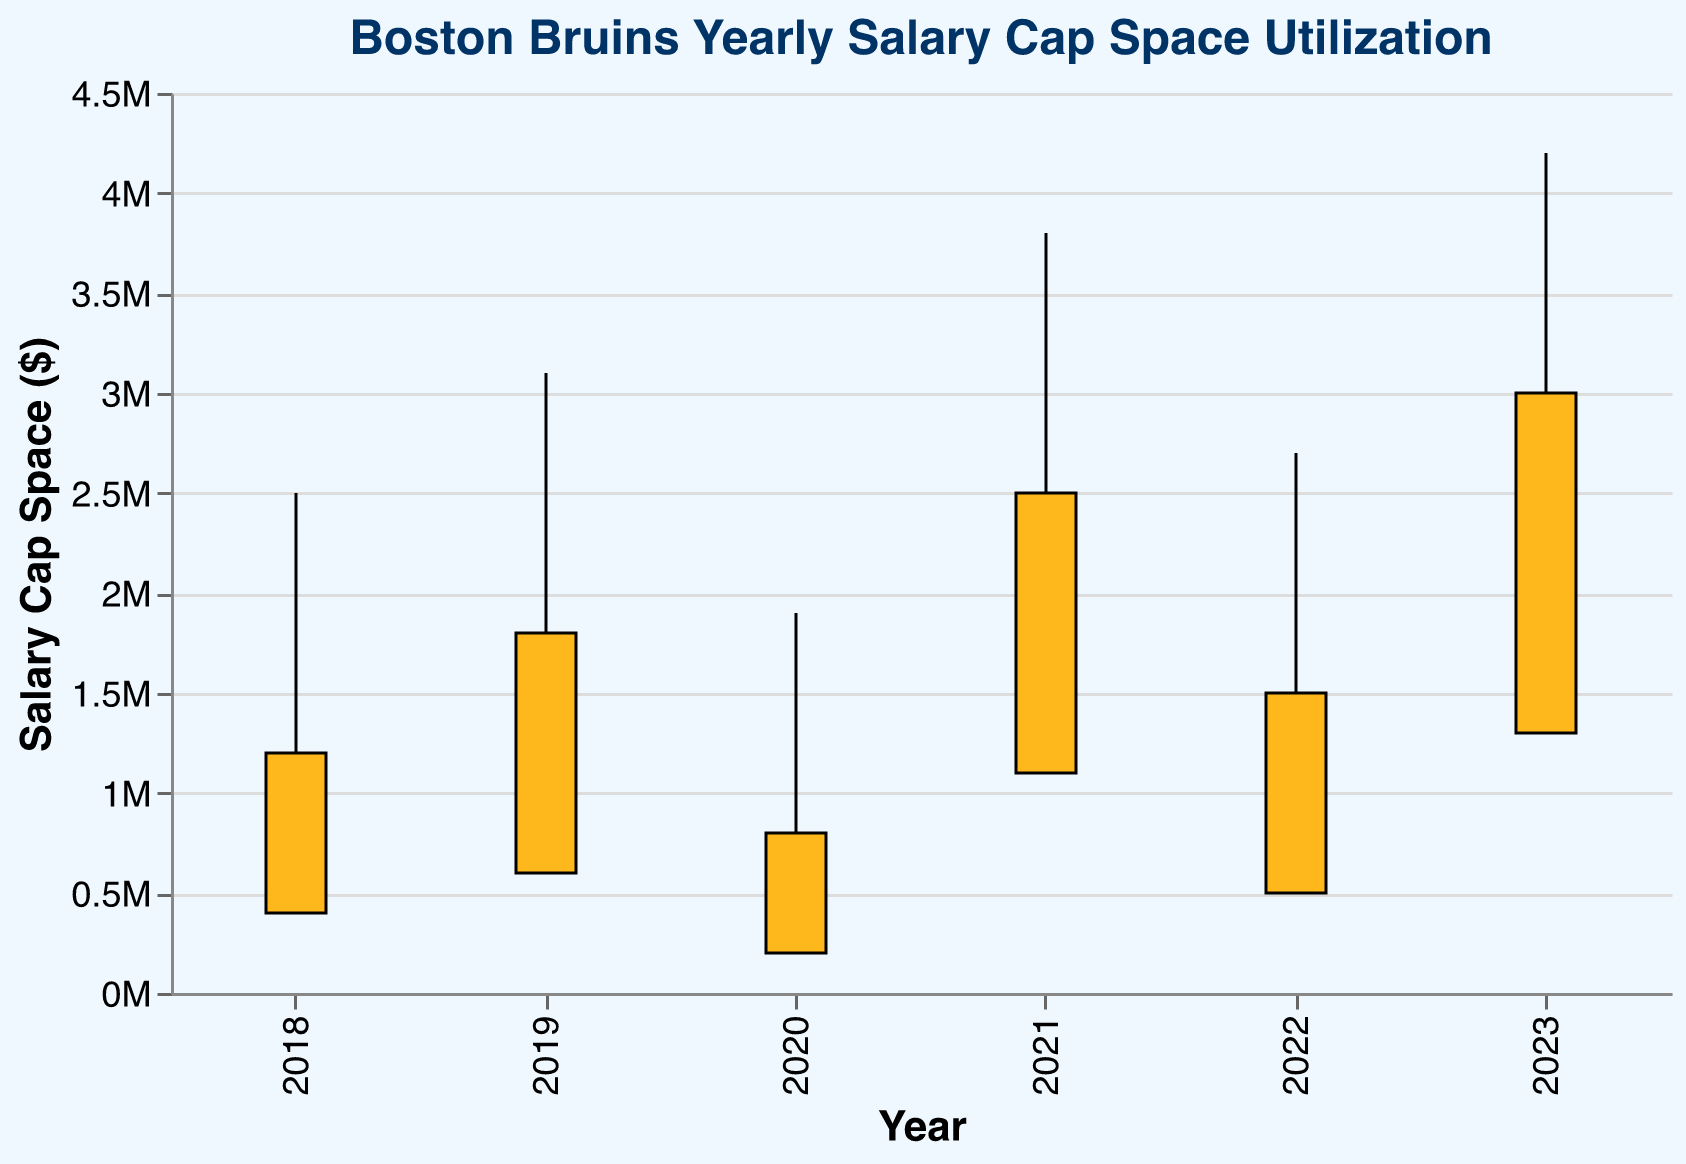What's the title of the chart? The title of the chart is always displayed at the top of the figure. For this chart, it says "Boston Bruins Yearly Salary Cap Space Utilization".
Answer: Boston Bruins Yearly Salary Cap Space Utilization What is the highest Opening Day salary cap space value, and in which year did it occur? The tallest point on the opening data rule corresponds to the highest value, which is $4,200,000 in 2023.
Answer: $4,200,000 in 2023 How does the salary cap space on the Trade Deadline compare between 2019 and 2020? Locate the bars representing the Trade Deadline values for 2019 and 2020. For 2019, it's $1,800,000, and for 2020, it's $800,000. So, the value in 2019 is greater.
Answer: 2019 is greater than 2020 In which year did the Boston Bruins have the least salary cap space at the season end, and what was that value? Identify the shortest bar at the bottom, representing the Season End salary cap space. The smallest value is $200,000 in 2020.
Answer: 2020, $200,000 What is the difference in salary cap space between Opening Day and Season End for 2021? Find the difference between the Opening Day value ($3,800,000) and the Season End value ($1,100,000) for 2021: $3,800,000 - $1,100,000 = $2,700,000.
Answer: $2,700,000 Calculate the average Opening Day salary cap space for the years provided. Sum the Opening Day values (2500000, 3100000, 1900000, 3800000, 2700000, 4200000), then divide by 6: (2500000 + 3100000 + 1900000 + 3800000 + 2700000 + 4200000) / 6 = 3033333.33.
Answer: $3,033,333.33 Which year showed the smallest drop in salary cap space from Opening Day to Trade Deadline? Calculate the difference for each year and find the smallest: 2018 (2500000 - 1200000), 2019 (3100000 - 1800000), 2020 (1900000 - 800000), 2021 (3800000 - 2500000), 2022 (2700000 - 1500000), 2023 (4200000 - 3000000). The smallest drop is 2023 ($1,200,000).
Answer: 2023 What is the difference in salary cap space between the highest and lowest year-end values? Identify the highest and lowest Season End values, $1,300,000 (2023) and $200,000 (2020). Difference: $1,300,000 - $200,000 = $1,100,000.
Answer: $1,100,000 Which year's Trade Deadline salary cap space aligns closest to $1,500,000? Compare the Trade Deadline values; the closest to $1,500,000 is 2022 with exactly $1,500,000.
Answer: 2022 What is the trend in Season End salary cap space from 2018 to 2023? Observing the bars from 2018 to 2023, the Season End values demonstrate a generally increasing trend, despite some fluctuations. From 2018 to 2019, the value increases and then decreases in 2020, only to rise again subsequently.
Answer: Increasing trend with fluctuations 